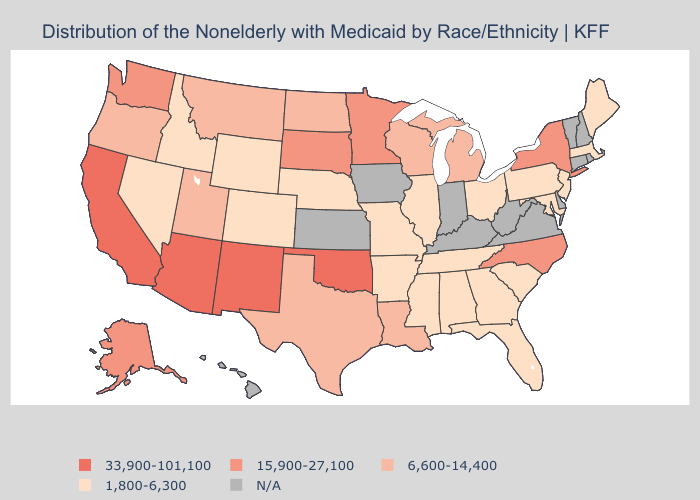What is the lowest value in the USA?
Write a very short answer. 1,800-6,300. What is the lowest value in the South?
Answer briefly. 1,800-6,300. Does the first symbol in the legend represent the smallest category?
Write a very short answer. No. Name the states that have a value in the range 6,600-14,400?
Keep it brief. Louisiana, Michigan, Montana, North Dakota, Oregon, Texas, Utah, Wisconsin. What is the lowest value in the USA?
Be succinct. 1,800-6,300. Name the states that have a value in the range 15,900-27,100?
Give a very brief answer. Alaska, Minnesota, New York, North Carolina, South Dakota, Washington. What is the value of Oregon?
Short answer required. 6,600-14,400. Among the states that border Delaware , which have the highest value?
Concise answer only. Maryland, New Jersey, Pennsylvania. What is the value of Mississippi?
Be succinct. 1,800-6,300. Name the states that have a value in the range 6,600-14,400?
Keep it brief. Louisiana, Michigan, Montana, North Dakota, Oregon, Texas, Utah, Wisconsin. What is the value of Oregon?
Short answer required. 6,600-14,400. Among the states that border California , does Arizona have the highest value?
Give a very brief answer. Yes. Name the states that have a value in the range 15,900-27,100?
Write a very short answer. Alaska, Minnesota, New York, North Carolina, South Dakota, Washington. What is the value of Illinois?
Give a very brief answer. 1,800-6,300. 